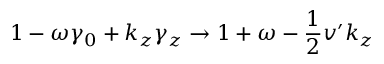Convert formula to latex. <formula><loc_0><loc_0><loc_500><loc_500>1 - \omega \gamma _ { 0 } + k _ { z } \gamma _ { z } \rightarrow 1 + \omega - \frac { 1 } { 2 } v ^ { \prime } k _ { z }</formula> 